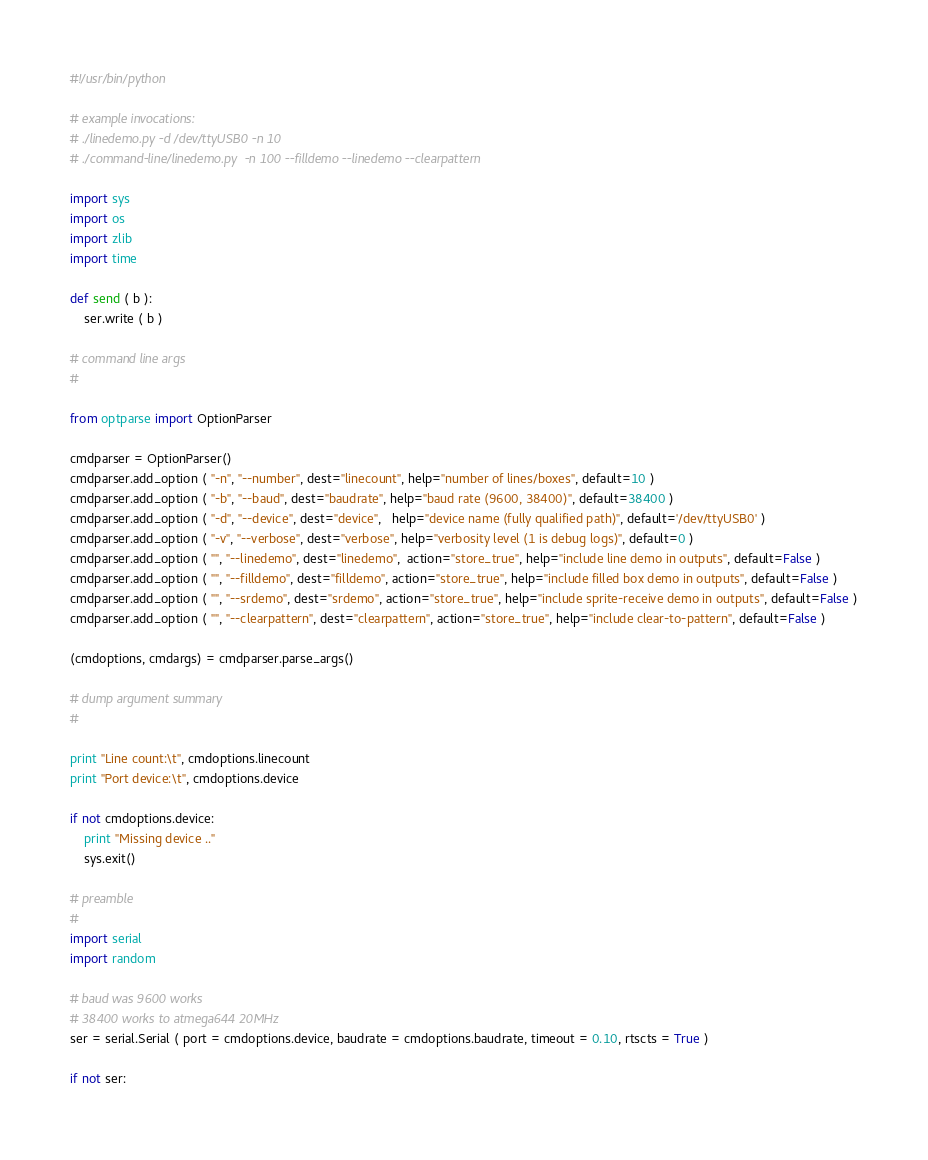Convert code to text. <code><loc_0><loc_0><loc_500><loc_500><_Python_>#!/usr/bin/python

# example invocations:
# ./linedemo.py -d /dev/ttyUSB0 -n 10
# ./command-line/linedemo.py  -n 100 --filldemo --linedemo --clearpattern

import sys
import os
import zlib
import time

def send ( b ):
    ser.write ( b )

# command line args
#

from optparse import OptionParser

cmdparser = OptionParser()
cmdparser.add_option ( "-n", "--number", dest="linecount", help="number of lines/boxes", default=10 )
cmdparser.add_option ( "-b", "--baud", dest="baudrate", help="baud rate (9600, 38400)", default=38400 )
cmdparser.add_option ( "-d", "--device", dest="device",   help="device name (fully qualified path)", default='/dev/ttyUSB0' )
cmdparser.add_option ( "-v", "--verbose", dest="verbose", help="verbosity level (1 is debug logs)", default=0 )
cmdparser.add_option ( "", "--linedemo", dest="linedemo",  action="store_true", help="include line demo in outputs", default=False )
cmdparser.add_option ( "", "--filldemo", dest="filldemo", action="store_true", help="include filled box demo in outputs", default=False )
cmdparser.add_option ( "", "--srdemo", dest="srdemo", action="store_true", help="include sprite-receive demo in outputs", default=False )
cmdparser.add_option ( "", "--clearpattern", dest="clearpattern", action="store_true", help="include clear-to-pattern", default=False )

(cmdoptions, cmdargs) = cmdparser.parse_args()

# dump argument summary
#

print "Line count:\t", cmdoptions.linecount
print "Port device:\t", cmdoptions.device

if not cmdoptions.device:
    print "Missing device .."
    sys.exit()

# preamble
#
import serial
import random

# baud was 9600 works
# 38400 works to atmega644 20MHz
ser = serial.Serial ( port = cmdoptions.device, baudrate = cmdoptions.baudrate, timeout = 0.10, rtscts = True )

if not ser:</code> 